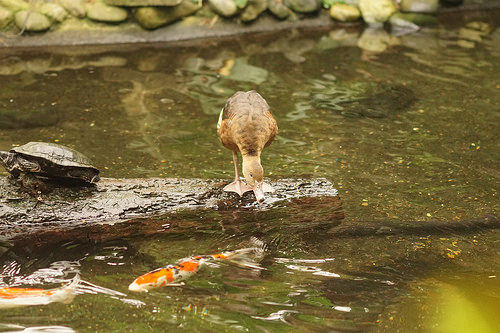<image>
Can you confirm if the turtle is in the water? No. The turtle is not contained within the water. These objects have a different spatial relationship. Where is the duck in relation to the fish? Is it above the fish? Yes. The duck is positioned above the fish in the vertical space, higher up in the scene. 